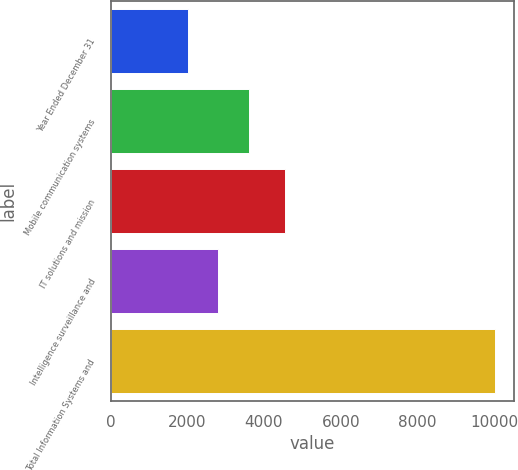<chart> <loc_0><loc_0><loc_500><loc_500><bar_chart><fcel>Year Ended December 31<fcel>Mobile communication systems<fcel>IT solutions and mission<fcel>Intelligence surveillance and<fcel>Total Information Systems and<nl><fcel>2012<fcel>3613<fcel>4545<fcel>2812.5<fcel>10017<nl></chart> 